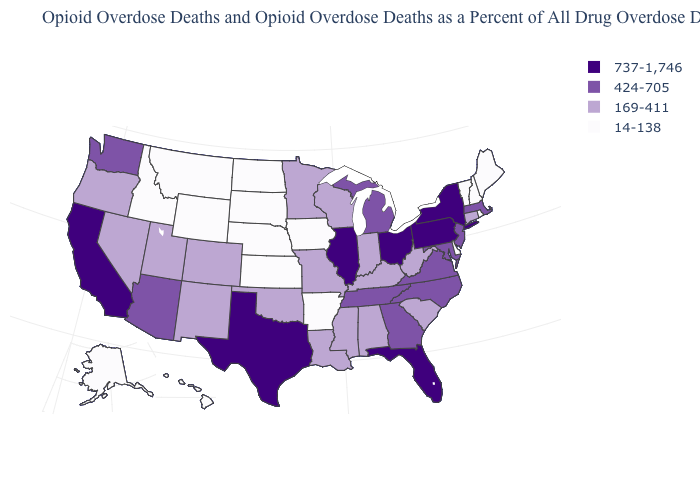Name the states that have a value in the range 14-138?
Be succinct. Alaska, Arkansas, Delaware, Hawaii, Idaho, Iowa, Kansas, Maine, Montana, Nebraska, New Hampshire, North Dakota, Rhode Island, South Dakota, Vermont, Wyoming. Name the states that have a value in the range 169-411?
Short answer required. Alabama, Colorado, Connecticut, Indiana, Kentucky, Louisiana, Minnesota, Mississippi, Missouri, Nevada, New Mexico, Oklahoma, Oregon, South Carolina, Utah, West Virginia, Wisconsin. What is the highest value in the USA?
Give a very brief answer. 737-1,746. What is the highest value in the USA?
Be succinct. 737-1,746. What is the value of Wyoming?
Concise answer only. 14-138. Does Wyoming have the same value as Arkansas?
Quick response, please. Yes. What is the lowest value in the West?
Keep it brief. 14-138. What is the lowest value in the USA?
Be succinct. 14-138. Name the states that have a value in the range 14-138?
Answer briefly. Alaska, Arkansas, Delaware, Hawaii, Idaho, Iowa, Kansas, Maine, Montana, Nebraska, New Hampshire, North Dakota, Rhode Island, South Dakota, Vermont, Wyoming. How many symbols are there in the legend?
Short answer required. 4. Does Rhode Island have the lowest value in the Northeast?
Be succinct. Yes. Name the states that have a value in the range 14-138?
Answer briefly. Alaska, Arkansas, Delaware, Hawaii, Idaho, Iowa, Kansas, Maine, Montana, Nebraska, New Hampshire, North Dakota, Rhode Island, South Dakota, Vermont, Wyoming. Does West Virginia have the same value as New York?
Short answer required. No. Name the states that have a value in the range 14-138?
Write a very short answer. Alaska, Arkansas, Delaware, Hawaii, Idaho, Iowa, Kansas, Maine, Montana, Nebraska, New Hampshire, North Dakota, Rhode Island, South Dakota, Vermont, Wyoming. 